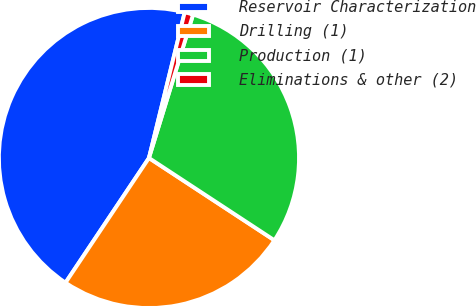Convert chart. <chart><loc_0><loc_0><loc_500><loc_500><pie_chart><fcel>Reservoir Characterization<fcel>Drilling (1)<fcel>Production (1)<fcel>Eliminations & other (2)<nl><fcel>44.44%<fcel>25.14%<fcel>29.49%<fcel>0.92%<nl></chart> 